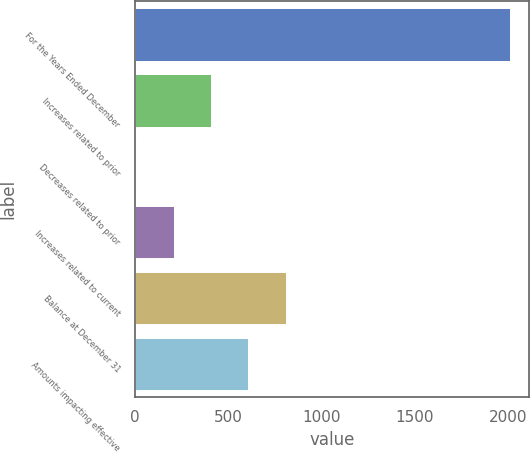Convert chart. <chart><loc_0><loc_0><loc_500><loc_500><bar_chart><fcel>For the Years Ended December<fcel>Increases related to prior<fcel>Decreases related to prior<fcel>Increases related to current<fcel>Balance at December 31<fcel>Amounts impacting effective<nl><fcel>2012<fcel>409.52<fcel>8.9<fcel>209.21<fcel>810.14<fcel>609.83<nl></chart> 